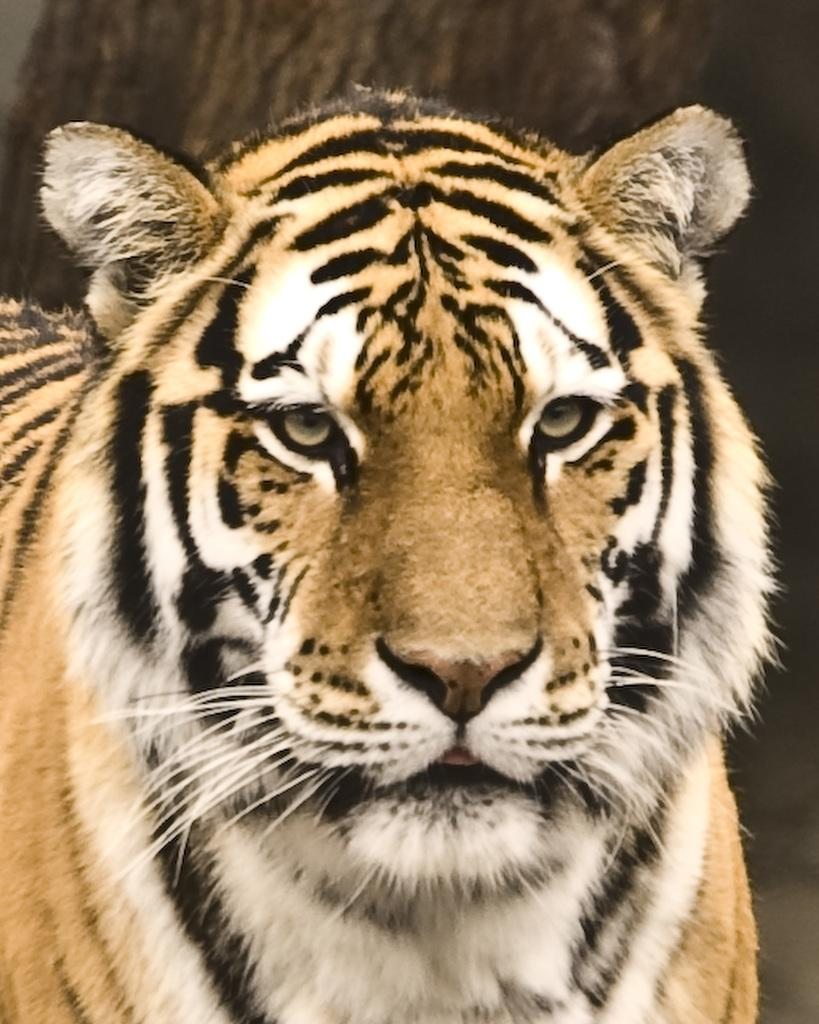What is the main subject of the image? The main subject of the image is a picture of a tiger. How close is the view of the tiger in the image? The picture of the tiger is zoomed in. Where is the tiger located in the image? The tiger is in the middle of the image. What type of cracker is the tiger holding in its mouth in the image? There is no cracker present in the image; it features a picture of a tiger. Can you see the tiger's wrist in the image? The image is a picture of a tiger, and it does not show the tiger's wrist. 